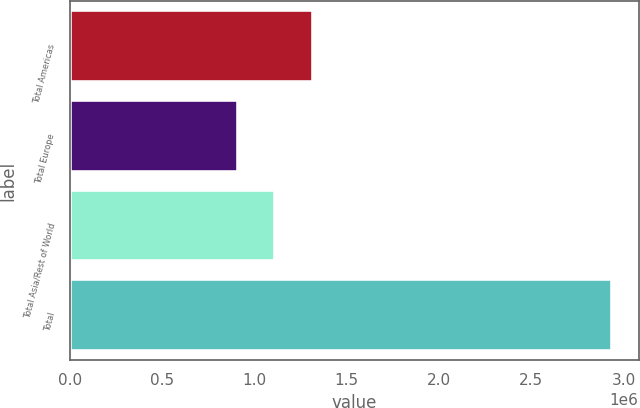Convert chart to OTSL. <chart><loc_0><loc_0><loc_500><loc_500><bar_chart><fcel>Total Americas<fcel>Total Europe<fcel>Total Asia/Rest of World<fcel>Total<nl><fcel>1.31414e+06<fcel>908773<fcel>1.11145e+06<fcel>2.93559e+06<nl></chart> 